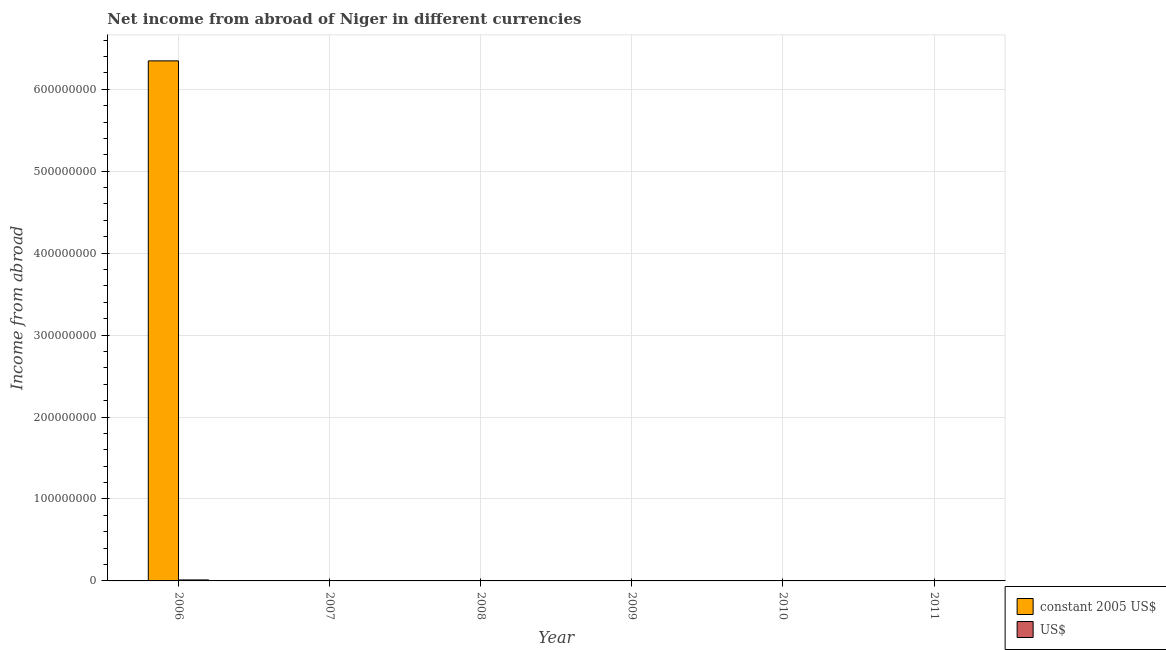Are the number of bars per tick equal to the number of legend labels?
Provide a short and direct response. No. What is the label of the 1st group of bars from the left?
Keep it short and to the point. 2006. In how many cases, is the number of bars for a given year not equal to the number of legend labels?
Your response must be concise. 5. What is the income from abroad in us$ in 2006?
Your answer should be compact. 1.21e+06. Across all years, what is the maximum income from abroad in constant 2005 us$?
Make the answer very short. 6.35e+08. In which year was the income from abroad in constant 2005 us$ maximum?
Offer a terse response. 2006. What is the total income from abroad in us$ in the graph?
Give a very brief answer. 1.21e+06. What is the average income from abroad in us$ per year?
Your answer should be very brief. 2.02e+05. In the year 2006, what is the difference between the income from abroad in us$ and income from abroad in constant 2005 us$?
Your answer should be very brief. 0. What is the difference between the highest and the lowest income from abroad in constant 2005 us$?
Give a very brief answer. 6.35e+08. In how many years, is the income from abroad in us$ greater than the average income from abroad in us$ taken over all years?
Offer a terse response. 1. Are all the bars in the graph horizontal?
Offer a very short reply. No. What is the difference between two consecutive major ticks on the Y-axis?
Your answer should be compact. 1.00e+08. Where does the legend appear in the graph?
Keep it short and to the point. Bottom right. How many legend labels are there?
Keep it short and to the point. 2. What is the title of the graph?
Your response must be concise. Net income from abroad of Niger in different currencies. Does "Female labor force" appear as one of the legend labels in the graph?
Your response must be concise. No. What is the label or title of the Y-axis?
Your response must be concise. Income from abroad. What is the Income from abroad of constant 2005 US$ in 2006?
Make the answer very short. 6.35e+08. What is the Income from abroad of US$ in 2006?
Ensure brevity in your answer.  1.21e+06. What is the Income from abroad of constant 2005 US$ in 2008?
Your answer should be very brief. 0. What is the Income from abroad of constant 2005 US$ in 2009?
Keep it short and to the point. 0. What is the Income from abroad in US$ in 2011?
Your response must be concise. 0. Across all years, what is the maximum Income from abroad in constant 2005 US$?
Give a very brief answer. 6.35e+08. Across all years, what is the maximum Income from abroad of US$?
Make the answer very short. 1.21e+06. Across all years, what is the minimum Income from abroad of constant 2005 US$?
Your response must be concise. 0. Across all years, what is the minimum Income from abroad in US$?
Ensure brevity in your answer.  0. What is the total Income from abroad of constant 2005 US$ in the graph?
Provide a succinct answer. 6.35e+08. What is the total Income from abroad of US$ in the graph?
Provide a short and direct response. 1.21e+06. What is the average Income from abroad in constant 2005 US$ per year?
Ensure brevity in your answer.  1.06e+08. What is the average Income from abroad of US$ per year?
Your answer should be compact. 2.02e+05. In the year 2006, what is the difference between the Income from abroad of constant 2005 US$ and Income from abroad of US$?
Your answer should be compact. 6.33e+08. What is the difference between the highest and the lowest Income from abroad of constant 2005 US$?
Give a very brief answer. 6.35e+08. What is the difference between the highest and the lowest Income from abroad in US$?
Give a very brief answer. 1.21e+06. 